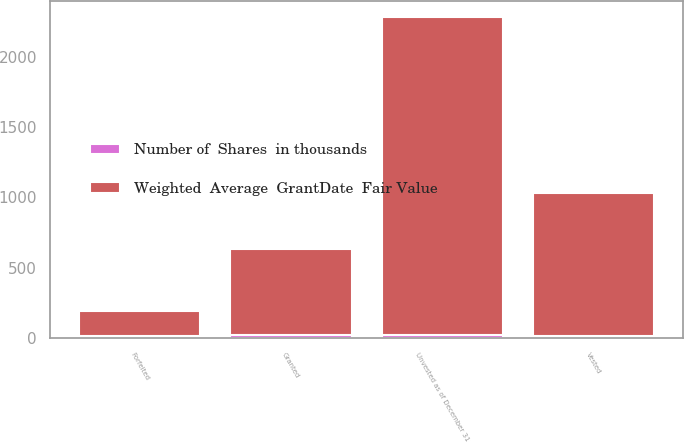<chart> <loc_0><loc_0><loc_500><loc_500><stacked_bar_chart><ecel><fcel>Unvested as of December 31<fcel>Forfeited<fcel>Vested<fcel>Granted<nl><fcel>Weighted  Average  GrantDate  Fair Value<fcel>2261<fcel>178<fcel>1018<fcel>616<nl><fcel>Number of  Shares  in thousands<fcel>20.21<fcel>14.27<fcel>10.31<fcel>19.16<nl></chart> 